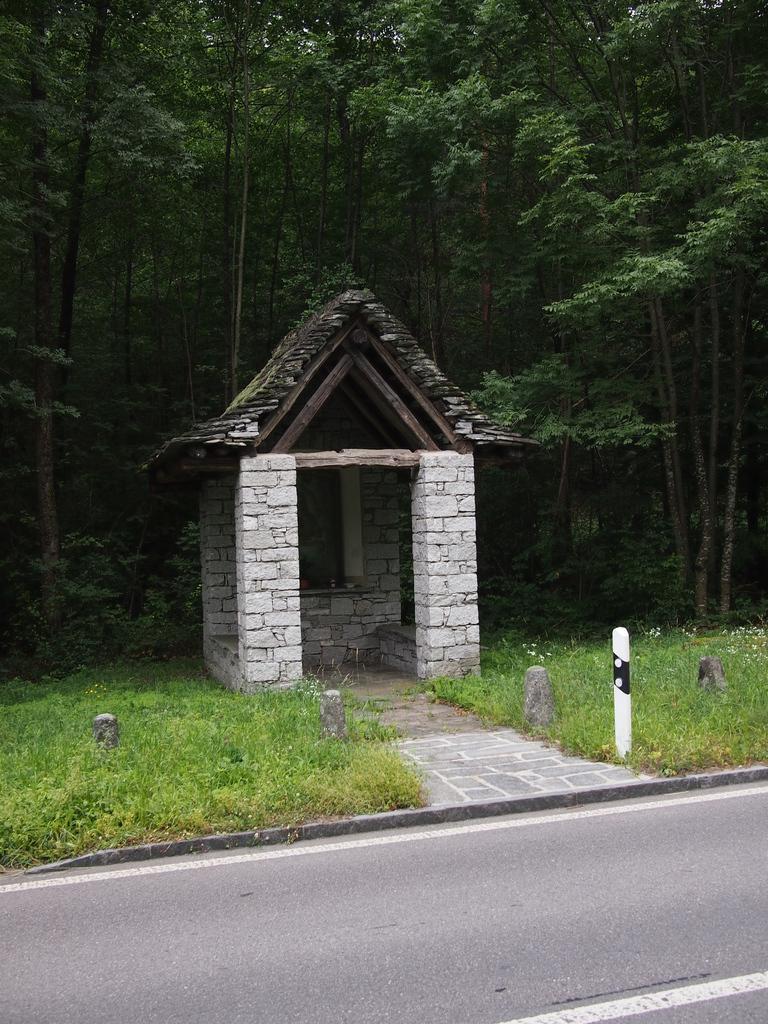In one or two sentences, can you explain what this image depicts? In this picture we can see a shelter in the middle, at the bottom there is grass, we can see some trees in the background. 